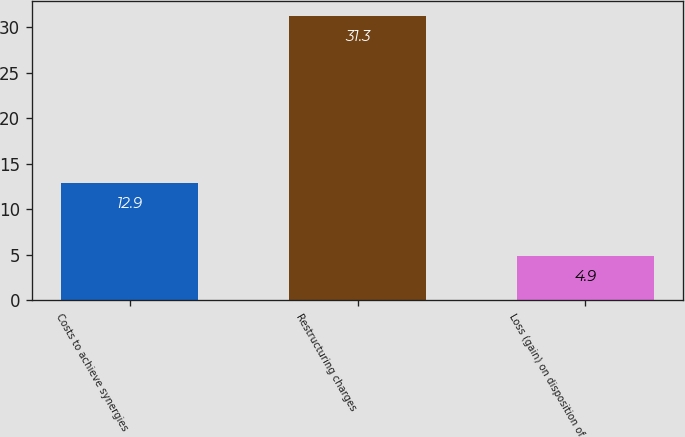Convert chart. <chart><loc_0><loc_0><loc_500><loc_500><bar_chart><fcel>Costs to achieve synergies<fcel>Restructuring charges<fcel>Loss (gain) on disposition of<nl><fcel>12.9<fcel>31.3<fcel>4.9<nl></chart> 